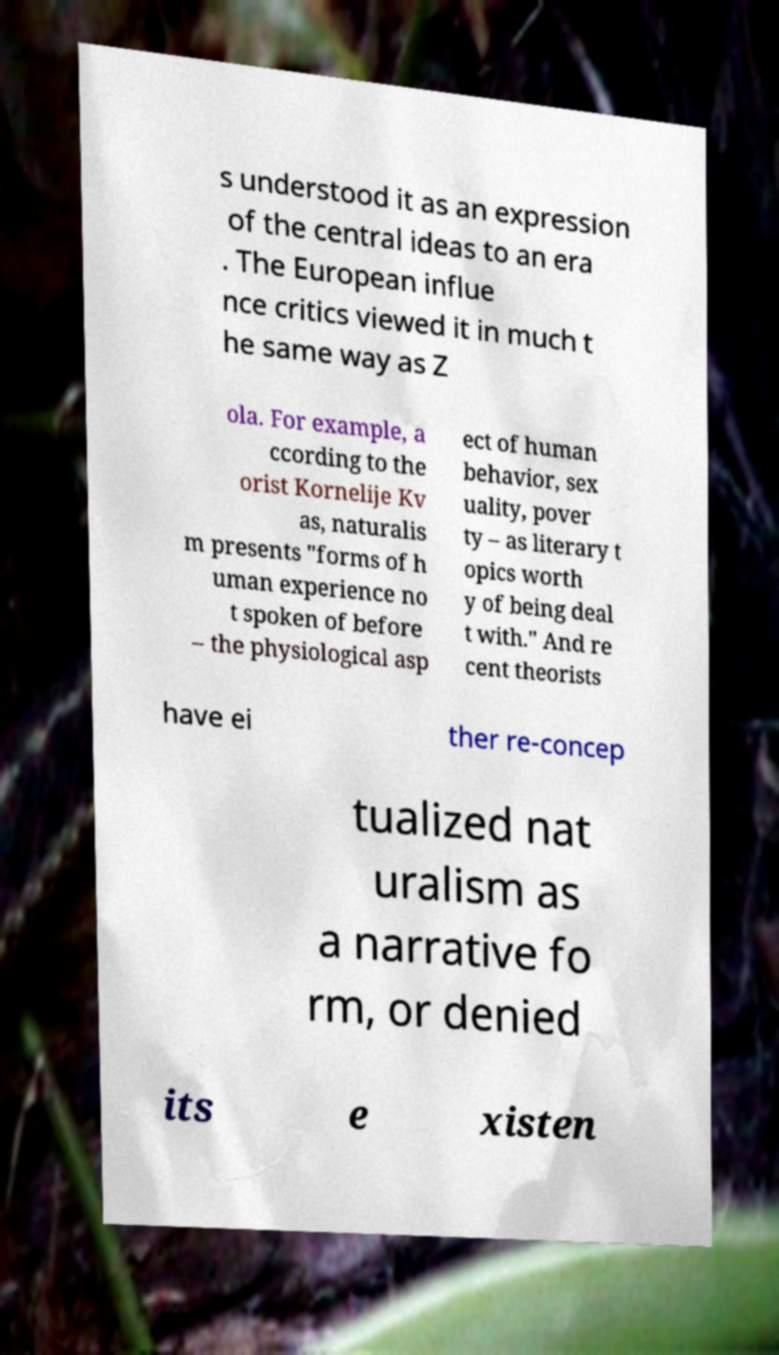There's text embedded in this image that I need extracted. Can you transcribe it verbatim? s understood it as an expression of the central ideas to an era . The European influe nce critics viewed it in much t he same way as Z ola. For example, a ccording to the orist Kornelije Kv as, naturalis m presents "forms of h uman experience no t spoken of before – the physiological asp ect of human behavior, sex uality, pover ty – as literary t opics worth y of being deal t with." And re cent theorists have ei ther re-concep tualized nat uralism as a narrative fo rm, or denied its e xisten 